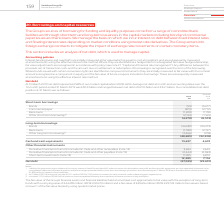From Vodafone Group Plc's financial document, Which financial years' information is shown in the table? The document shows two values: 2018 and 2019. From the document: "159 Vodafone Group Plc Annual Report 2019 ebt represented 58% of our market capitalisation (2018: 46%). Average net debt at month end accounting dates..." Also, What type of short term borrowings are shown in the table? The document contains multiple relevant values: Bonds, Commercial paper, Bank loans, Other short-term borrowings. From the document: "al paper (873) (2,712) Bank loans (1,220) (1,159) Other short-term borrowings 2 (2,124) (1,165) (4,270) (8,513) Short-term borrowings Bonds (53) (3,47..." Also, What type of long-term borrowings are shown in the table? The document contains multiple relevant values: Bonds, Bank loans, Other long-term borrowings. From the document: "Bonds (53) (3,477) Commercial paper (873) (2,712) Bank loans (1,220) (1,159) Other short-term borrowings 2 (2,124) (1,165) (4,270) (8,513) Short-term ..." Also, can you calculate: What is the average Short-term investments for 2018 and 2019? To answer this question, I need to perform calculations using the financial data. The calculation is: (11,095+ 6,870)/2, which equals 8982.5 (in millions). This is based on the information: ") (2,383) Short-term investments (note 13) 11,095 6,870 12,285 7,116 Net debt (27,033) (29,631) (2,444) (2,383) Short-term investments (note 13) 11,095 6,870 12,285 7,116 Net debt (27,033) (29,631)..." The key data points involved are: 11,095, 6,870. Also, can you calculate: What is the change in Cash and cash equivalents between 2018 and 2019? Based on the calculation: 13,637-4,674, the result is 8963 (in millions). This is based on the information: "Cash and cash equivalents 13,637 4,674 Cash and cash equivalents 13,637 4,674..." The key data points involved are: 13,637, 4,674. Additionally, Which year has the highest value of Cash and cash equivalents? According to the financial document, 2019 (in millions). The relevant text states: "159 Vodafone Group Plc Annual Report 2019..." 